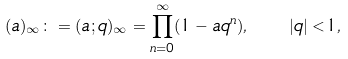<formula> <loc_0><loc_0><loc_500><loc_500>( a ) _ { \infty } \colon = ( a ; q ) _ { \infty } = \prod _ { n = 0 } ^ { \infty } ( 1 - a q ^ { n } ) , \quad | q | < 1 ,</formula> 